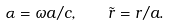Convert formula to latex. <formula><loc_0><loc_0><loc_500><loc_500>\alpha = \omega a / c , \quad \tilde { r } = r / a .</formula> 